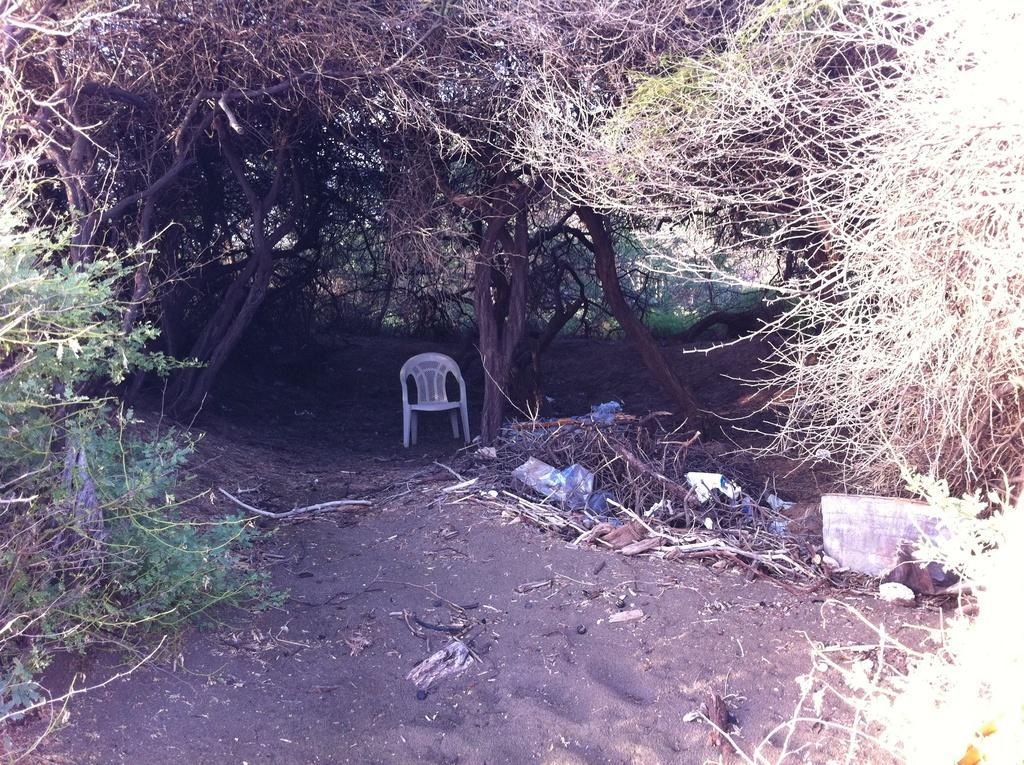Please provide a concise description of this image. In this picture we can see a chair on the ground, sticks and some objects and in the background we can see trees. 